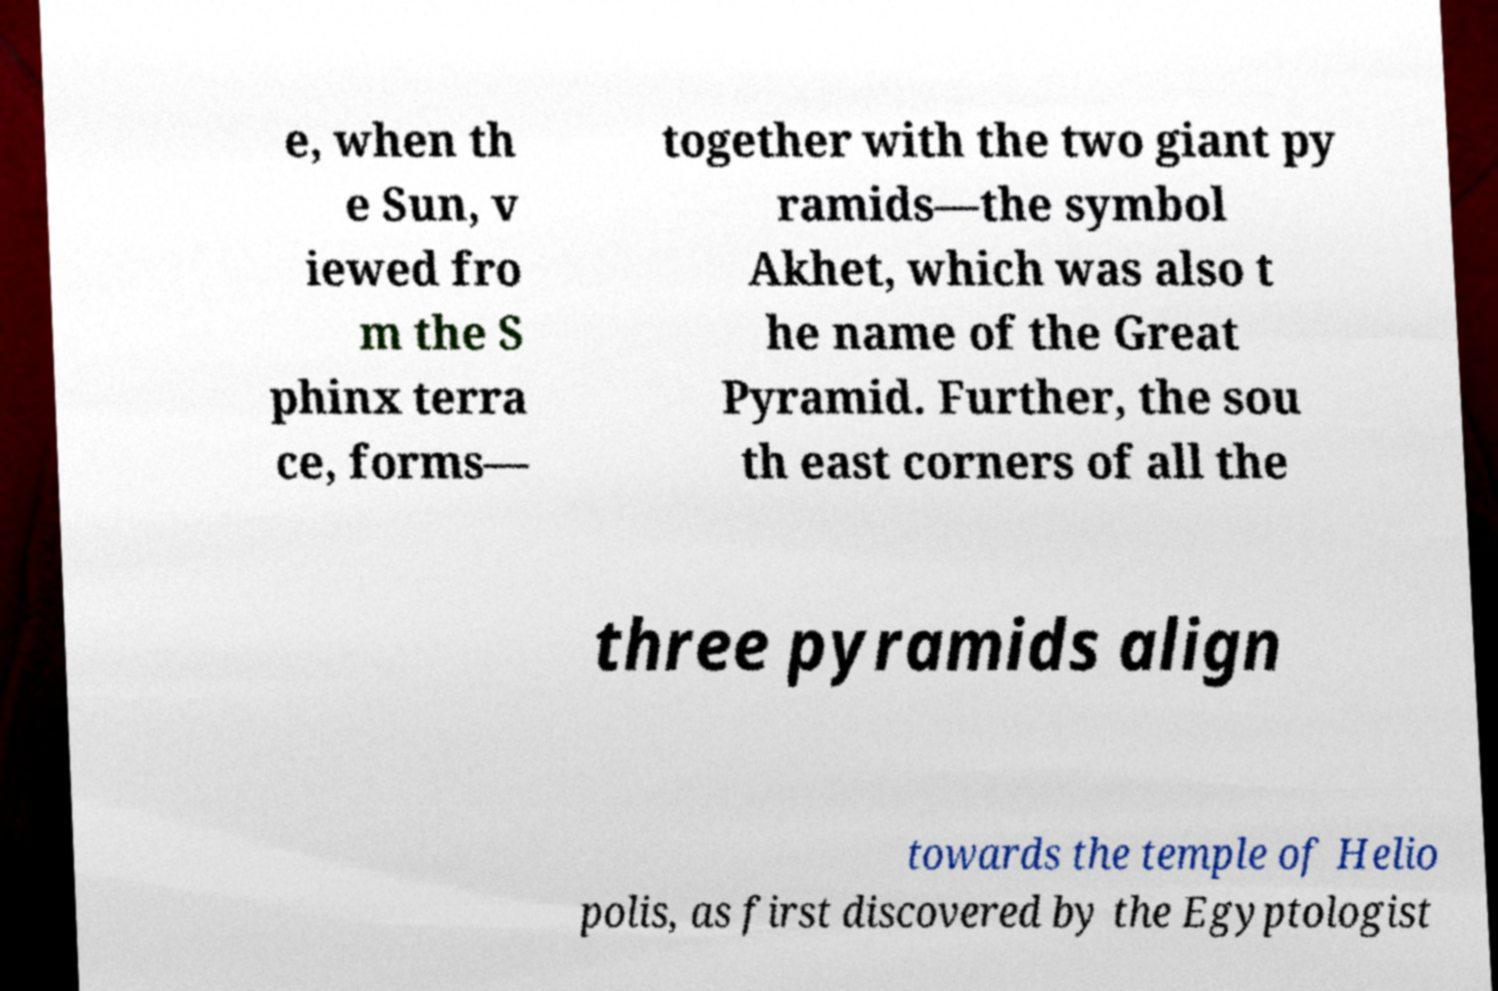Please read and relay the text visible in this image. What does it say? e, when th e Sun, v iewed fro m the S phinx terra ce, forms— together with the two giant py ramids—the symbol Akhet, which was also t he name of the Great Pyramid. Further, the sou th east corners of all the three pyramids align towards the temple of Helio polis, as first discovered by the Egyptologist 